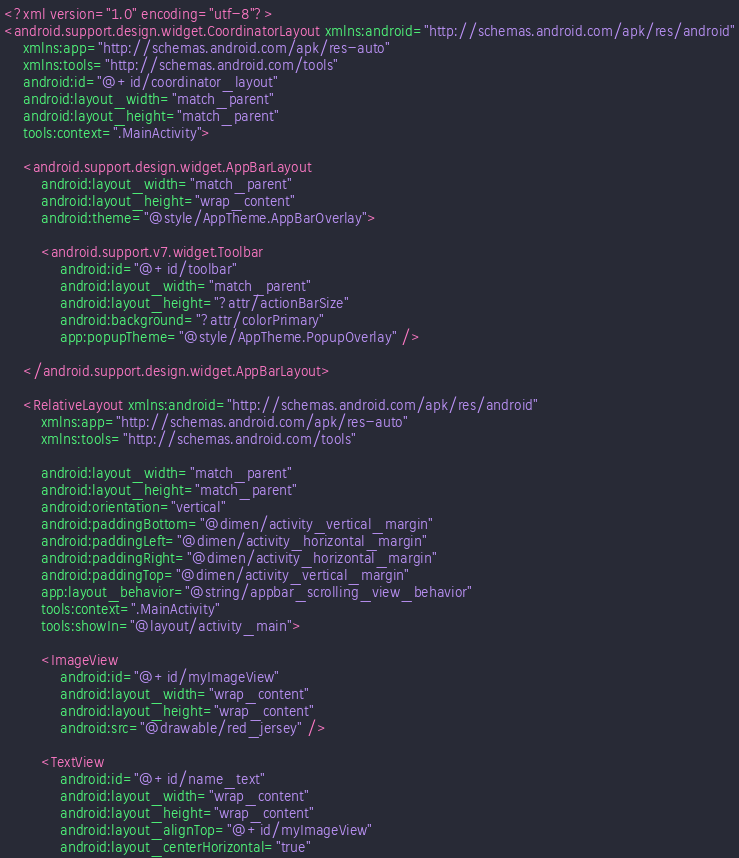Convert code to text. <code><loc_0><loc_0><loc_500><loc_500><_XML_><?xml version="1.0" encoding="utf-8"?>
<android.support.design.widget.CoordinatorLayout xmlns:android="http://schemas.android.com/apk/res/android"
    xmlns:app="http://schemas.android.com/apk/res-auto"
    xmlns:tools="http://schemas.android.com/tools"
    android:id="@+id/coordinator_layout"
    android:layout_width="match_parent"
    android:layout_height="match_parent"
    tools:context=".MainActivity">

    <android.support.design.widget.AppBarLayout
        android:layout_width="match_parent"
        android:layout_height="wrap_content"
        android:theme="@style/AppTheme.AppBarOverlay">

        <android.support.v7.widget.Toolbar
            android:id="@+id/toolbar"
            android:layout_width="match_parent"
            android:layout_height="?attr/actionBarSize"
            android:background="?attr/colorPrimary"
            app:popupTheme="@style/AppTheme.PopupOverlay" />

    </android.support.design.widget.AppBarLayout>

    <RelativeLayout xmlns:android="http://schemas.android.com/apk/res/android"
        xmlns:app="http://schemas.android.com/apk/res-auto"
        xmlns:tools="http://schemas.android.com/tools"

        android:layout_width="match_parent"
        android:layout_height="match_parent"
        android:orientation="vertical"
        android:paddingBottom="@dimen/activity_vertical_margin"
        android:paddingLeft="@dimen/activity_horizontal_margin"
        android:paddingRight="@dimen/activity_horizontal_margin"
        android:paddingTop="@dimen/activity_vertical_margin"
        app:layout_behavior="@string/appbar_scrolling_view_behavior"
        tools:context=".MainActivity"
        tools:showIn="@layout/activity_main">

        <ImageView
            android:id="@+id/myImageView"
            android:layout_width="wrap_content"
            android:layout_height="wrap_content"
            android:src="@drawable/red_jersey" />

        <TextView
            android:id="@+id/name_text"
            android:layout_width="wrap_content"
            android:layout_height="wrap_content"
            android:layout_alignTop="@+id/myImageView"
            android:layout_centerHorizontal="true"</code> 